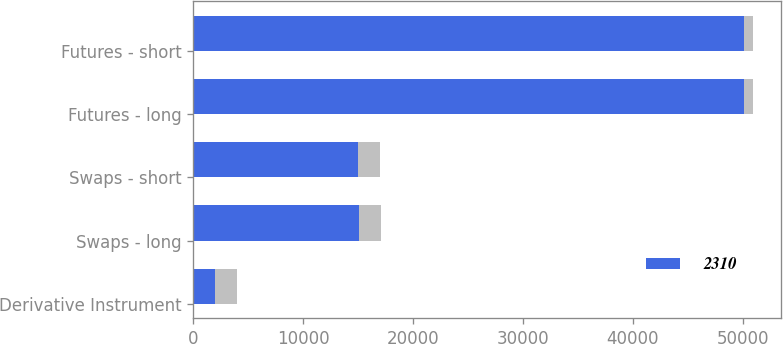Convert chart. <chart><loc_0><loc_0><loc_500><loc_500><stacked_bar_chart><ecel><fcel>Derivative Instrument<fcel>Swaps - long<fcel>Swaps - short<fcel>Futures - long<fcel>Futures - short<nl><fcel>2310<fcel>2012<fcel>15128<fcel>14968<fcel>50126<fcel>50133<nl><fcel>nan<fcel>2013<fcel>2000<fcel>2000<fcel>825<fcel>825<nl></chart> 